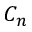<formula> <loc_0><loc_0><loc_500><loc_500>C _ { n }</formula> 